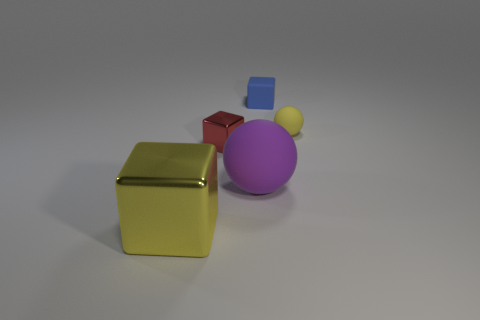Subtract all metal blocks. How many blocks are left? 1 Add 4 big yellow metallic blocks. How many objects exist? 9 Subtract all purple balls. How many balls are left? 1 Subtract all cubes. How many objects are left? 2 Subtract 2 cubes. How many cubes are left? 1 Add 2 matte objects. How many matte objects are left? 5 Add 1 big yellow rubber blocks. How many big yellow rubber blocks exist? 1 Subtract 0 purple cylinders. How many objects are left? 5 Subtract all brown spheres. Subtract all brown cubes. How many spheres are left? 2 Subtract all gray blocks. How many yellow spheres are left? 1 